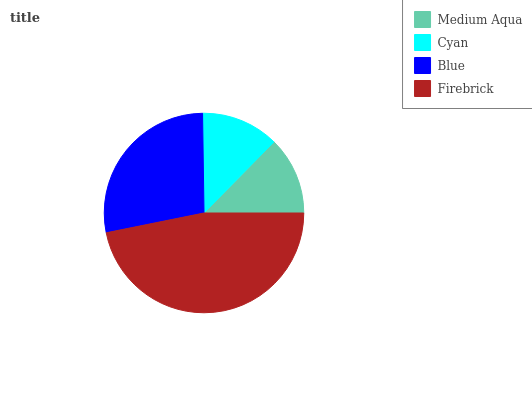Is Cyan the minimum?
Answer yes or no. Yes. Is Firebrick the maximum?
Answer yes or no. Yes. Is Blue the minimum?
Answer yes or no. No. Is Blue the maximum?
Answer yes or no. No. Is Blue greater than Cyan?
Answer yes or no. Yes. Is Cyan less than Blue?
Answer yes or no. Yes. Is Cyan greater than Blue?
Answer yes or no. No. Is Blue less than Cyan?
Answer yes or no. No. Is Blue the high median?
Answer yes or no. Yes. Is Medium Aqua the low median?
Answer yes or no. Yes. Is Medium Aqua the high median?
Answer yes or no. No. Is Firebrick the low median?
Answer yes or no. No. 